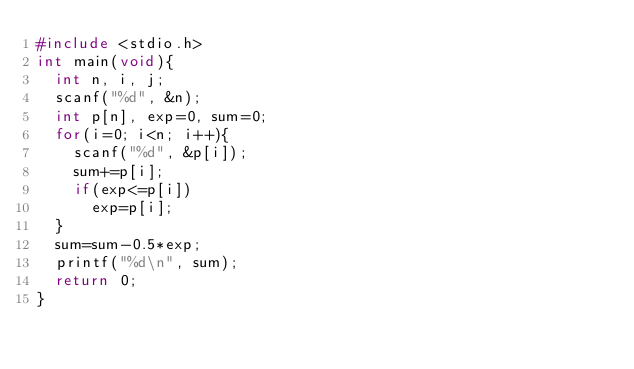Convert code to text. <code><loc_0><loc_0><loc_500><loc_500><_C_>#include <stdio.h>
int main(void){
  int n, i, j;
  scanf("%d", &n);
  int p[n], exp=0, sum=0;
  for(i=0; i<n; i++){
    scanf("%d", &p[i]);
    sum+=p[i];
    if(exp<=p[i])
      exp=p[i];
  }
  sum=sum-0.5*exp;
  printf("%d\n", sum);
  return 0;
}</code> 